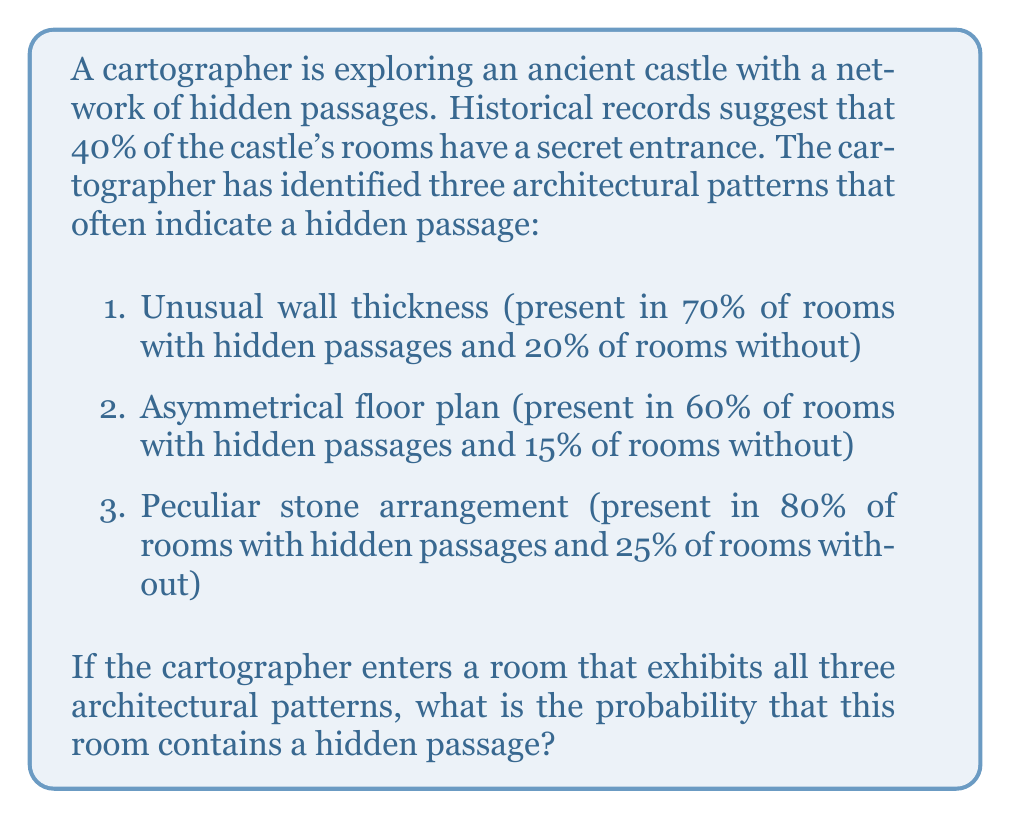Solve this math problem. Let's approach this problem using Bayes' theorem. We'll define the following events:

$H$: The room has a hidden passage
$P$: The room exhibits all three architectural patterns

We need to calculate $P(H|P)$, the probability of a hidden passage given the presence of all three patterns.

Bayes' theorem states:

$$P(H|P) = \frac{P(P|H) \cdot P(H)}{P(P)}$$

Given:
$P(H) = 0.40$ (40% of rooms have a hidden passage)
$P(\text{not }H) = 1 - P(H) = 0.60$

To find $P(P|H)$, we multiply the probabilities of each pattern given a hidden passage:
$$P(P|H) = 0.70 \cdot 0.60 \cdot 0.80 = 0.336$$

To find $P(P|\text{not }H)$, we multiply the probabilities of each pattern given no hidden passage:
$$P(P|\text{not }H) = 0.20 \cdot 0.15 \cdot 0.25 = 0.0075$$

Now we can calculate $P(P)$ using the law of total probability:
$$P(P) = P(P|H) \cdot P(H) + P(P|\text{not }H) \cdot P(\text{not }H)$$
$$P(P) = 0.336 \cdot 0.40 + 0.0075 \cdot 0.60 = 0.1344 + 0.0045 = 0.1389$$

Finally, we can apply Bayes' theorem:

$$P(H|P) = \frac{P(P|H) \cdot P(H)}{P(P)} = \frac{0.336 \cdot 0.40}{0.1389} \approx 0.9683$$
Answer: The probability that the room contains a hidden passage, given that it exhibits all three architectural patterns, is approximately 0.9683 or 96.83%. 